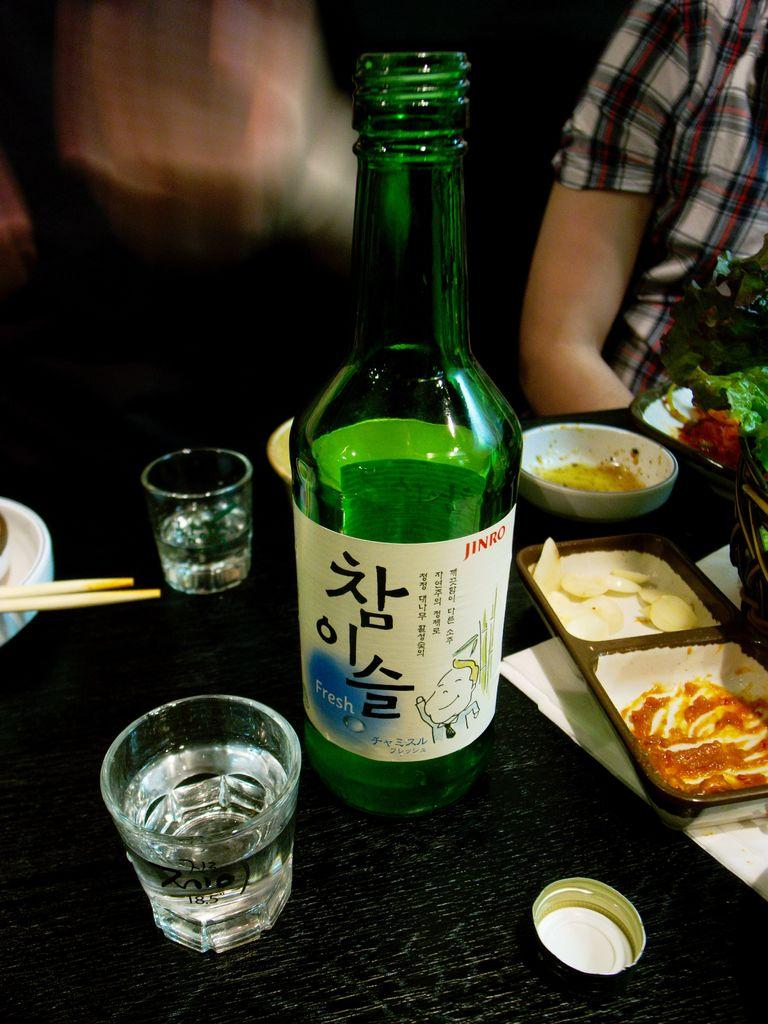<image>
Give a short and clear explanation of the subsequent image. A Japenaese bottle of Jinro is on a table with short glasses and Japanese food on a table. 